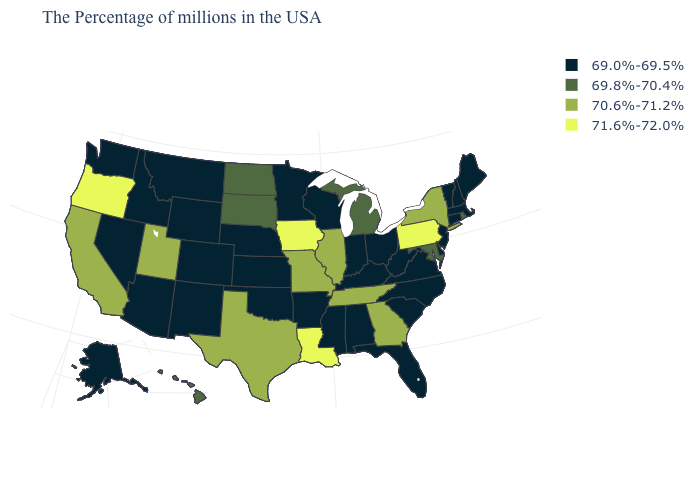What is the value of New Hampshire?
Quick response, please. 69.0%-69.5%. How many symbols are there in the legend?
Concise answer only. 4. What is the value of Mississippi?
Short answer required. 69.0%-69.5%. Name the states that have a value in the range 69.8%-70.4%?
Keep it brief. Rhode Island, Maryland, Michigan, South Dakota, North Dakota, Hawaii. What is the highest value in the USA?
Keep it brief. 71.6%-72.0%. What is the value of Oklahoma?
Write a very short answer. 69.0%-69.5%. Does Wyoming have the highest value in the USA?
Quick response, please. No. Which states have the highest value in the USA?
Quick response, please. Pennsylvania, Louisiana, Iowa, Oregon. What is the value of Illinois?
Keep it brief. 70.6%-71.2%. What is the lowest value in states that border Arizona?
Answer briefly. 69.0%-69.5%. Does the map have missing data?
Write a very short answer. No. Which states hav the highest value in the MidWest?
Quick response, please. Iowa. Does Pennsylvania have the highest value in the Northeast?
Write a very short answer. Yes. What is the value of North Dakota?
Concise answer only. 69.8%-70.4%. What is the value of New Mexico?
Keep it brief. 69.0%-69.5%. 